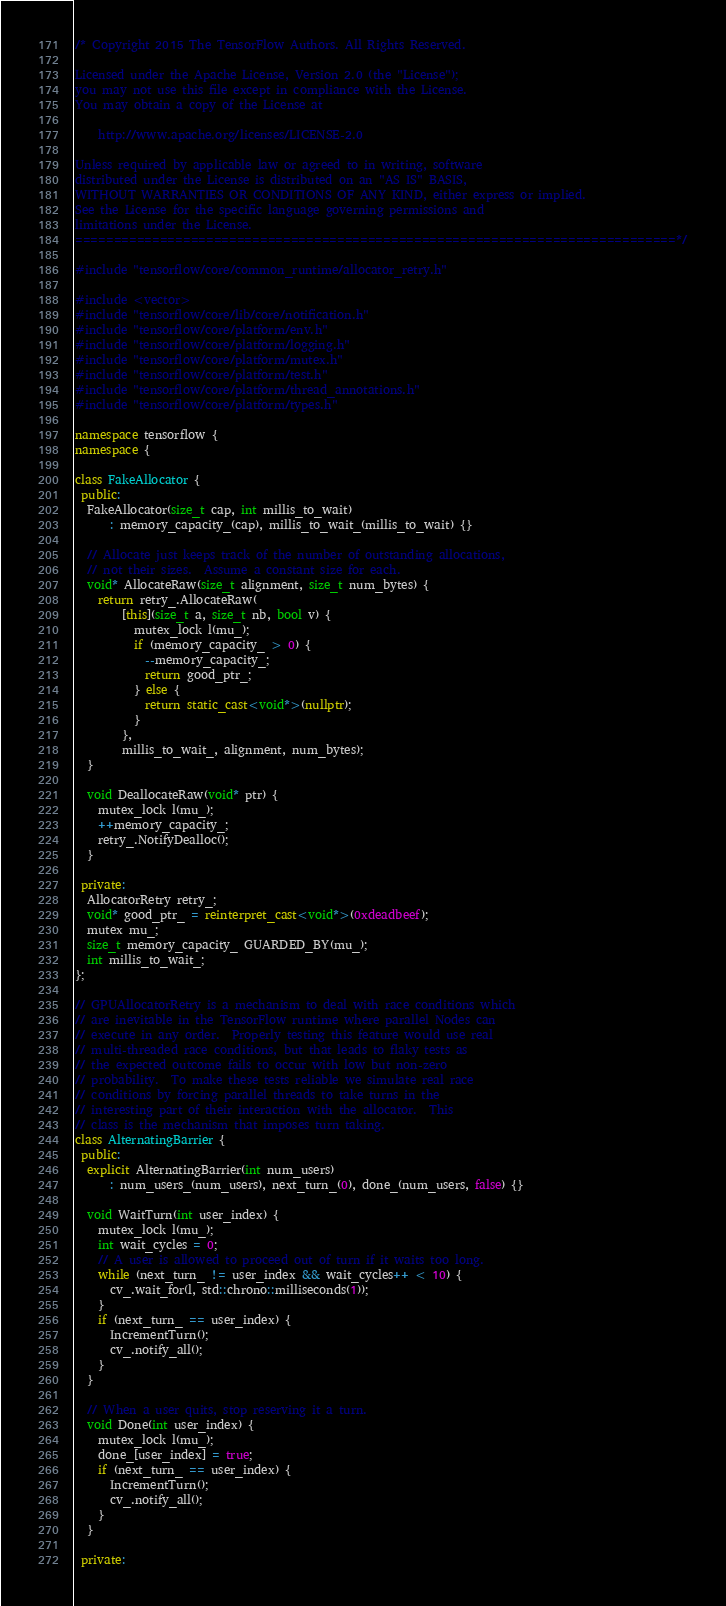<code> <loc_0><loc_0><loc_500><loc_500><_C++_>/* Copyright 2015 The TensorFlow Authors. All Rights Reserved.

Licensed under the Apache License, Version 2.0 (the "License");
you may not use this file except in compliance with the License.
You may obtain a copy of the License at

    http://www.apache.org/licenses/LICENSE-2.0

Unless required by applicable law or agreed to in writing, software
distributed under the License is distributed on an "AS IS" BASIS,
WITHOUT WARRANTIES OR CONDITIONS OF ANY KIND, either express or implied.
See the License for the specific language governing permissions and
limitations under the License.
==============================================================================*/

#include "tensorflow/core/common_runtime/allocator_retry.h"

#include <vector>
#include "tensorflow/core/lib/core/notification.h"
#include "tensorflow/core/platform/env.h"
#include "tensorflow/core/platform/logging.h"
#include "tensorflow/core/platform/mutex.h"
#include "tensorflow/core/platform/test.h"
#include "tensorflow/core/platform/thread_annotations.h"
#include "tensorflow/core/platform/types.h"

namespace tensorflow {
namespace {

class FakeAllocator {
 public:
  FakeAllocator(size_t cap, int millis_to_wait)
      : memory_capacity_(cap), millis_to_wait_(millis_to_wait) {}

  // Allocate just keeps track of the number of outstanding allocations,
  // not their sizes.  Assume a constant size for each.
  void* AllocateRaw(size_t alignment, size_t num_bytes) {
    return retry_.AllocateRaw(
        [this](size_t a, size_t nb, bool v) {
          mutex_lock l(mu_);
          if (memory_capacity_ > 0) {
            --memory_capacity_;
            return good_ptr_;
          } else {
            return static_cast<void*>(nullptr);
          }
        },
        millis_to_wait_, alignment, num_bytes);
  }

  void DeallocateRaw(void* ptr) {
    mutex_lock l(mu_);
    ++memory_capacity_;
    retry_.NotifyDealloc();
  }

 private:
  AllocatorRetry retry_;
  void* good_ptr_ = reinterpret_cast<void*>(0xdeadbeef);
  mutex mu_;
  size_t memory_capacity_ GUARDED_BY(mu_);
  int millis_to_wait_;
};

// GPUAllocatorRetry is a mechanism to deal with race conditions which
// are inevitable in the TensorFlow runtime where parallel Nodes can
// execute in any order.  Properly testing this feature would use real
// multi-threaded race conditions, but that leads to flaky tests as
// the expected outcome fails to occur with low but non-zero
// probability.  To make these tests reliable we simulate real race
// conditions by forcing parallel threads to take turns in the
// interesting part of their interaction with the allocator.  This
// class is the mechanism that imposes turn taking.
class AlternatingBarrier {
 public:
  explicit AlternatingBarrier(int num_users)
      : num_users_(num_users), next_turn_(0), done_(num_users, false) {}

  void WaitTurn(int user_index) {
    mutex_lock l(mu_);
    int wait_cycles = 0;
    // A user is allowed to proceed out of turn if it waits too long.
    while (next_turn_ != user_index && wait_cycles++ < 10) {
      cv_.wait_for(l, std::chrono::milliseconds(1));
    }
    if (next_turn_ == user_index) {
      IncrementTurn();
      cv_.notify_all();
    }
  }

  // When a user quits, stop reserving it a turn.
  void Done(int user_index) {
    mutex_lock l(mu_);
    done_[user_index] = true;
    if (next_turn_ == user_index) {
      IncrementTurn();
      cv_.notify_all();
    }
  }

 private:</code> 